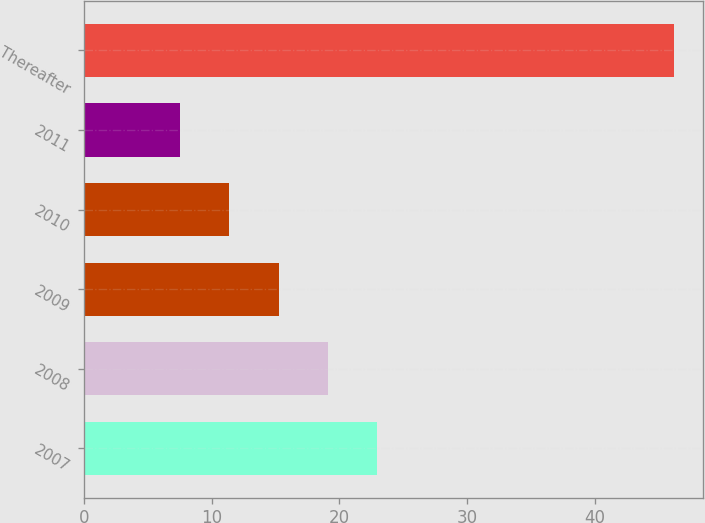<chart> <loc_0><loc_0><loc_500><loc_500><bar_chart><fcel>2007<fcel>2008<fcel>2009<fcel>2010<fcel>2011<fcel>Thereafter<nl><fcel>22.98<fcel>19.11<fcel>15.24<fcel>11.37<fcel>7.5<fcel>46.2<nl></chart> 